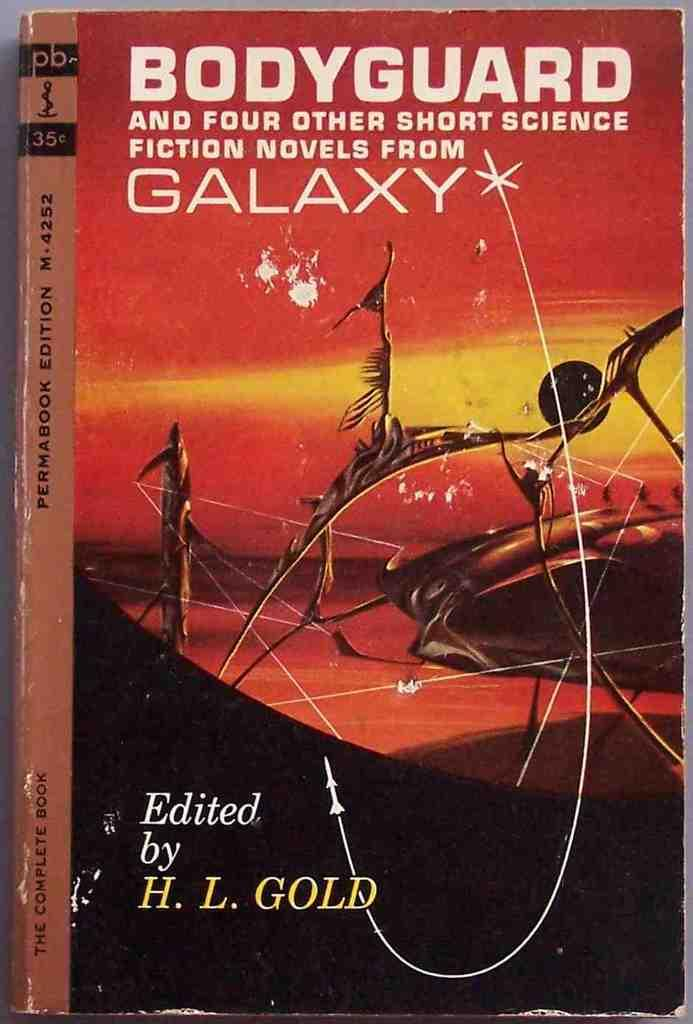<image>
Give a short and clear explanation of the subsequent image. A paperback science fiction book titled Bodyguard and Four Other Short Science Fiction Novels from Galaxy. 